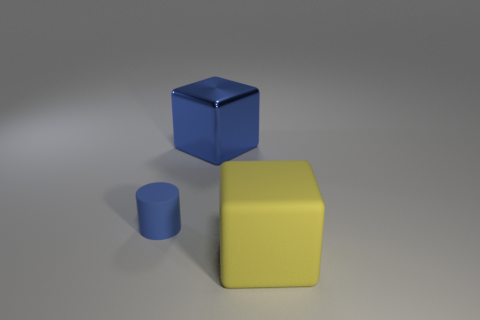What textures are visible on the objects present in the image? The large yellow cube appears to have a matte texture, absorbing light without reflection. The smaller blue cylinder has a slightly reflective matte finish, suggesting it might be made of rubber or a similar material. Finally, the blue cube displays a shiny, reflective surface indicative of a metallic or plastic material. 